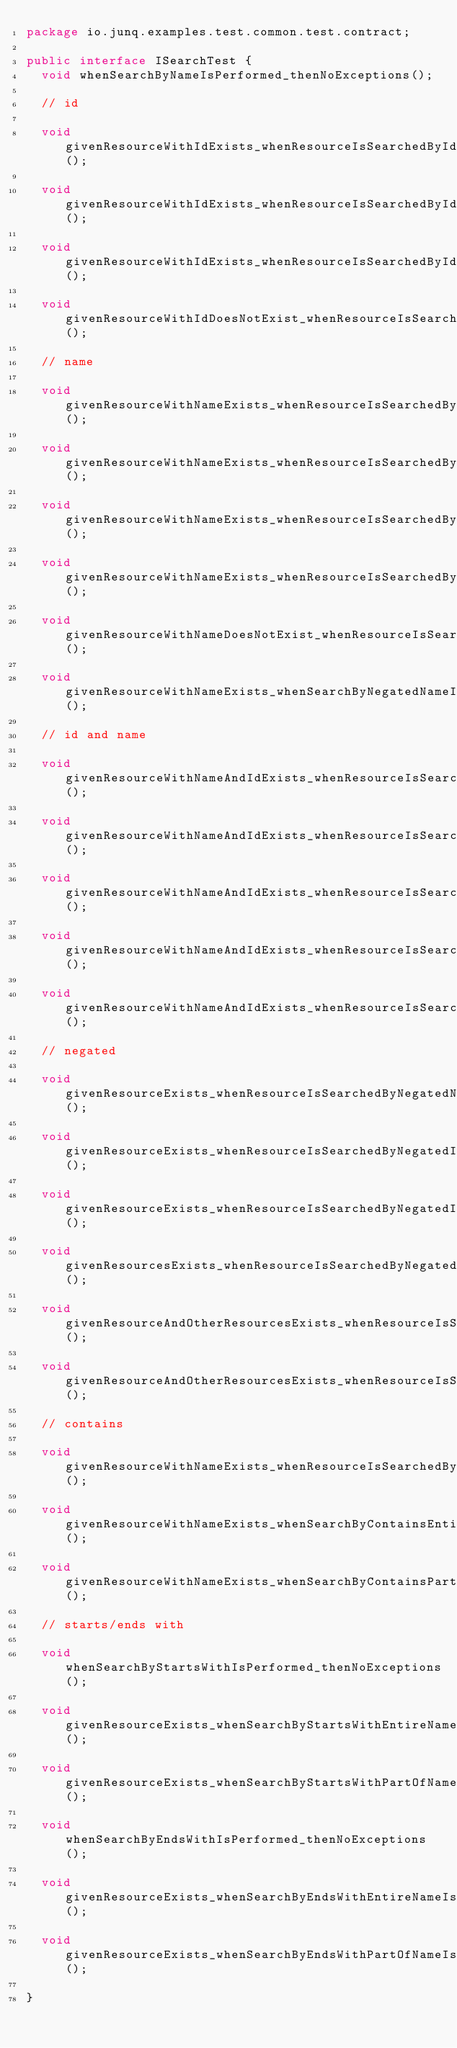Convert code to text. <code><loc_0><loc_0><loc_500><loc_500><_Java_>package io.junq.examples.test.common.test.contract;

public interface ISearchTest {
	void whenSearchByNameIsPerformed_thenNoExceptions();

	// id

	void givenResourceWithIdExists_whenResourceIsSearchedById_thenNoExceptions();

	void givenResourceWithIdExists_whenResourceIsSearchedById_thenSearchOperationIsSuccessful();

	void givenResourceWithIdExists_whenResourceIsSearchedById_thenResourceIsFound();

	void givenResourceWithIdDoesNotExist_whenResourceIsSearchedById_thenResourceIsNotFound();

	// name

	void givenResourceWithNameExists_whenResourceIsSearchedByName_thenNoExceptions();

	void givenResourceWithNameExists_whenResourceIsSearchedByName_thenOperationIsSuccessful();

	void givenResourceWithNameExists_whenResourceIsSearchedByName_thenResourceIsFound();

	void givenResourceWithNameExists_whenResourceIsSearchedByNameLowerCase_thenResourceIsFound();

	void givenResourceWithNameDoesNotExist_whenResourceIsSearchedByName_thenResourceIsNotFound();

	void givenResourceWithNameExists_whenSearchByNegatedNameIsPerformed_thenResourcesAreCorrect();

	// id and name

	void givenResourceWithNameAndIdExists_whenResourceIsSearchedByCorrectIdAndCorrectName_thenOperationIsSuccessful();

	void givenResourceWithNameAndIdExists_whenResourceIsSearchedByCorrectIdAndCorrectName_thenResourceIsFound();

	void givenResourceWithNameAndIdExists_whenResourceIsSearchedByIncorrectIdAndCorrectName_thenResourceIsNotFound();

	void givenResourceWithNameAndIdExists_whenResourceIsSearchedByCorrectIdAndIncorrectName_thenResourceIsNotFound();

	void givenResourceWithNameAndIdExists_whenResourceIsSearchedByIncorrectIdAndIncorrectName_thenResourceIsNotFound();

	// negated

	void givenResourceExists_whenResourceIsSearchedByNegatedName_thenOperationIsSuccessful();

	void givenResourceExists_whenResourceIsSearchedByNegatedId_thenOperationIsSuccessful();

	void givenResourceExists_whenResourceIsSearchedByNegatedId_thenResourceIsNotFound();

	void givenResourcesExists_whenResourceIsSearchedByNegatedId_thenTheOtherResourcesAreFound();

	void givenResourceAndOtherResourcesExists_whenResourceIsSearchedByNegatedName_thenResourcesAreFound();

	void givenResourceAndOtherResourcesExists_whenResourceIsSearchedByNegatedId_thenResourcesAreFound();

	// contains

	void givenResourceWithNameExists_whenResourceIsSearchedByContainsExactName_thenNoExceptions();

	void givenResourceWithNameExists_whenSearchByContainsEntireNameIsPerformed_thenResourceIsFound();

	void givenResourceWithNameExists_whenSearchByContainsPartOfNameIsPerformed_thenResourceIsFound();

	// starts/ends with

	void whenSearchByStartsWithIsPerformed_thenNoExceptions();

	void givenResourceExists_whenSearchByStartsWithEntireNameIsPerformed_thenResourceIsFound();

	void givenResourceExists_whenSearchByStartsWithPartOfNameIsPerformed_thenResourceIsFound();

	void whenSearchByEndsWithIsPerformed_thenNoExceptions();

	void givenResourceExists_whenSearchByEndsWithEntireNameIsPerformed_thenResourceIsFound();

	void givenResourceExists_whenSearchByEndsWithPartOfNameIsPerformed_thenResourceIsFound();

}
</code> 